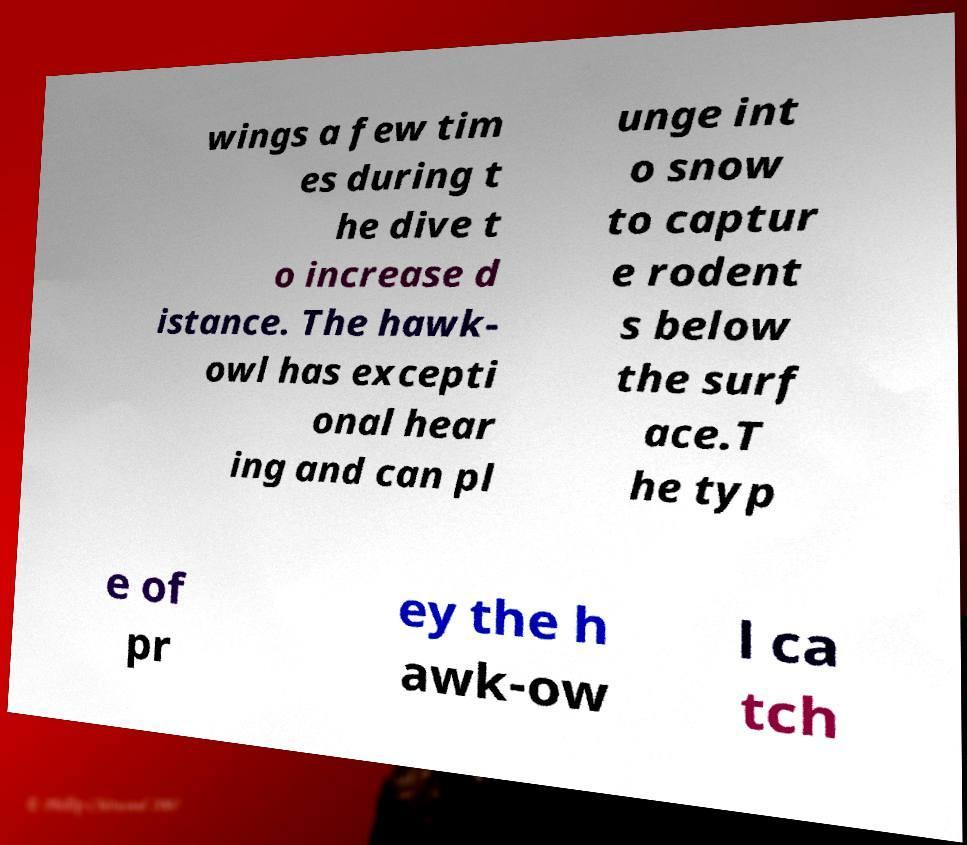What messages or text are displayed in this image? I need them in a readable, typed format. wings a few tim es during t he dive t o increase d istance. The hawk- owl has excepti onal hear ing and can pl unge int o snow to captur e rodent s below the surf ace.T he typ e of pr ey the h awk-ow l ca tch 